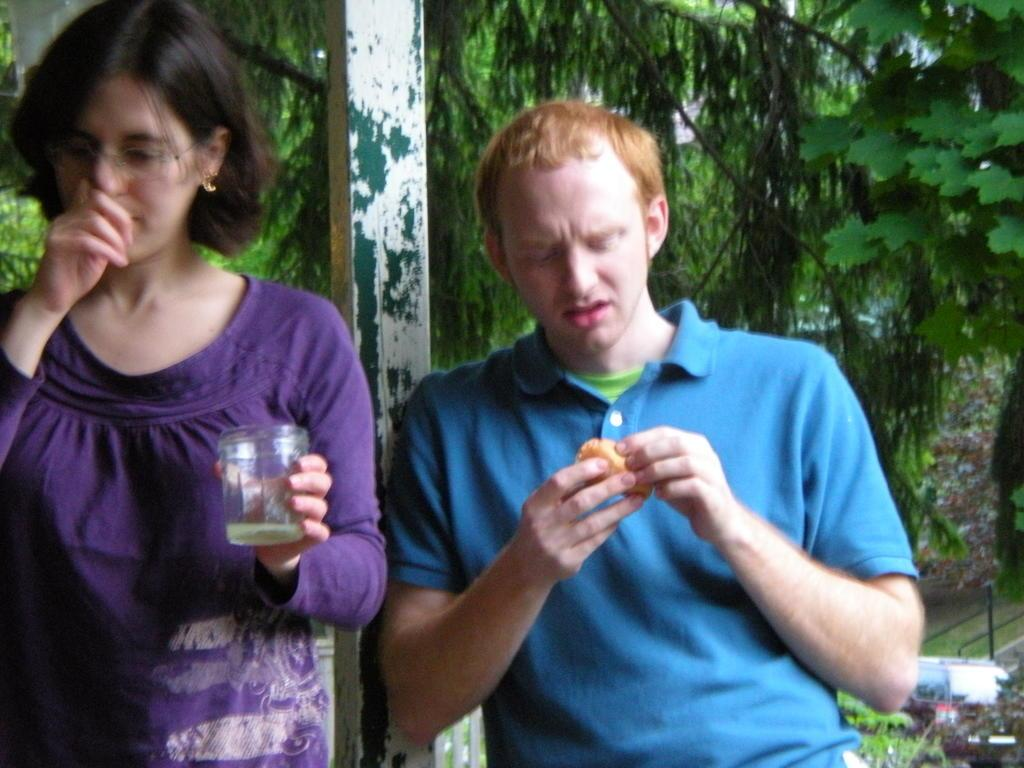Who or what can be seen in the image? There are people in the image. What are the people doing in the image? The people are holding objects. What can be seen in the distance in the image? There are trees and poles visible in the background of the image. Can you hear the minister crying in the image? There is no minister or crying present in the image. 